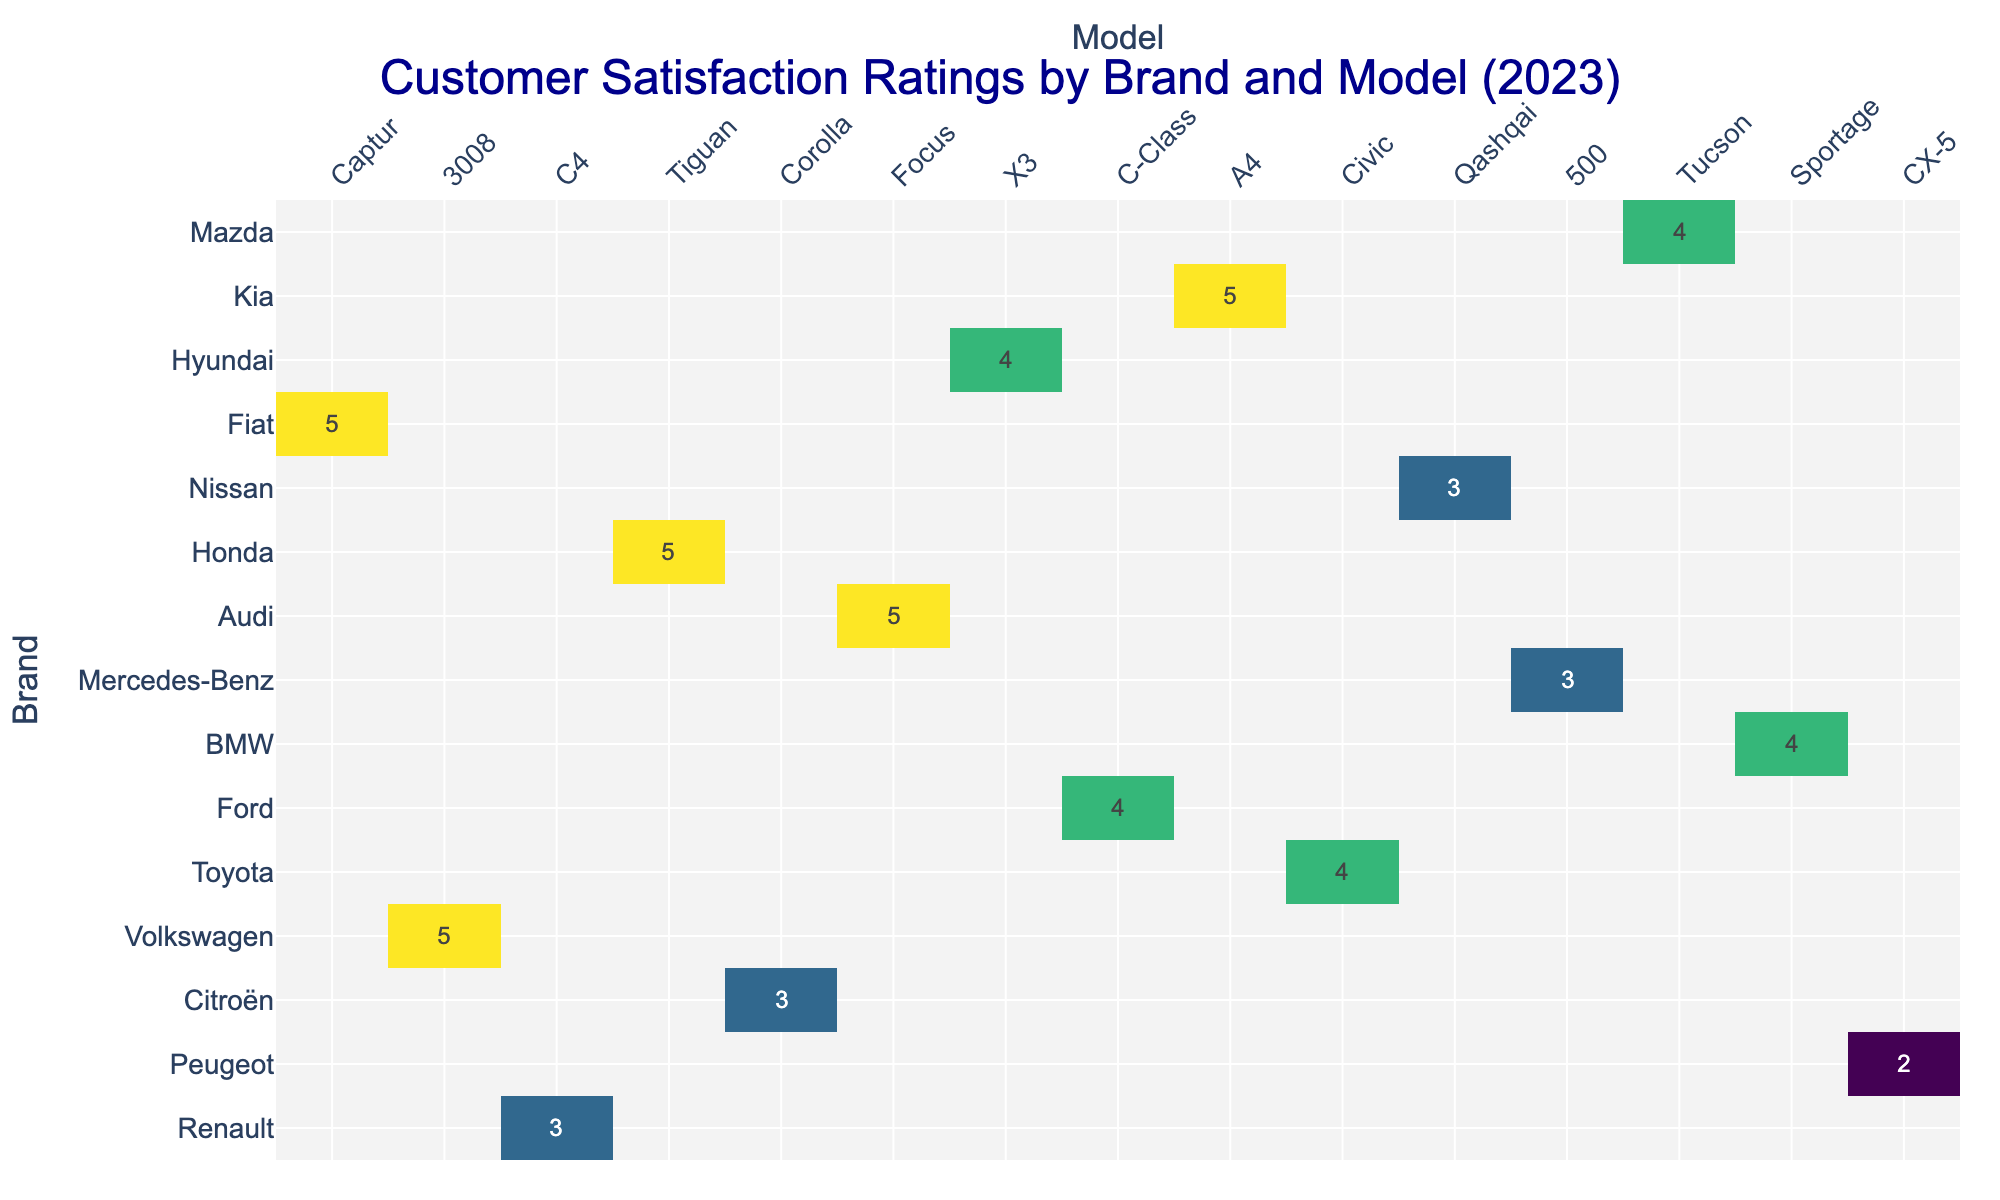What is the satisfaction rating for the Citroën C4? The rating is found in the row for Citroën under the column for C4. The recorded satisfaction rating is 3.
Answer: 3 Which brand has the highest satisfaction rating? By inspecting the ratings across all brands, we determine that Mercedes-Benz has a satisfaction rating of 5, which is the highest among all listed brands.
Answer: Mercedes-Benz Is there any brand that received a satisfaction rating of 2? Looking through the ratings, only BMW has a satisfaction rating of 2.
Answer: Yes What is the average satisfaction rating for Toyota models? The data shows one Toyota model, the Corolla, with a rating of 5. Since there is only one model, the average satisfaction rating is the same as that of the Corolla, which is 5.
Answer: 5 How many brands received a satisfaction rating of 5? The brands with a rating of 5 are Peugeot, Toyota, Mercedes-Benz, Fiat, and Mazda, making a total of 5 brands.
Answer: 5 What is the difference between the highest and lowest satisfaction ratings? The highest rating in the table is 5 (from multiple brands) and the lowest is 2 (from BMW). Thus, the difference is 5 - 2 = 3.
Answer: 3 Do all models from Renault have higher satisfaction ratings than models from Nissan? Renault has the Captur rated at 4, whereas Nissan’s Qashqai is rated at 3. Since 4 is greater than 3, the answer is yes.
Answer: Yes What is the total number of unique vehicle models listed in the ratings? The models listed are Captur, 3008, C4, Tiguan, Corolla, Focus, X3, C-Class, A4, Civic, Qashqai, 500, Tucson, Sportage, and CX-5, totaling 15 unique models.
Answer: 15 Which model has the lowest satisfaction rating? The BMW X3 has the lowest satisfaction rating of 2, as indicated in the table.
Answer: BMW X3 